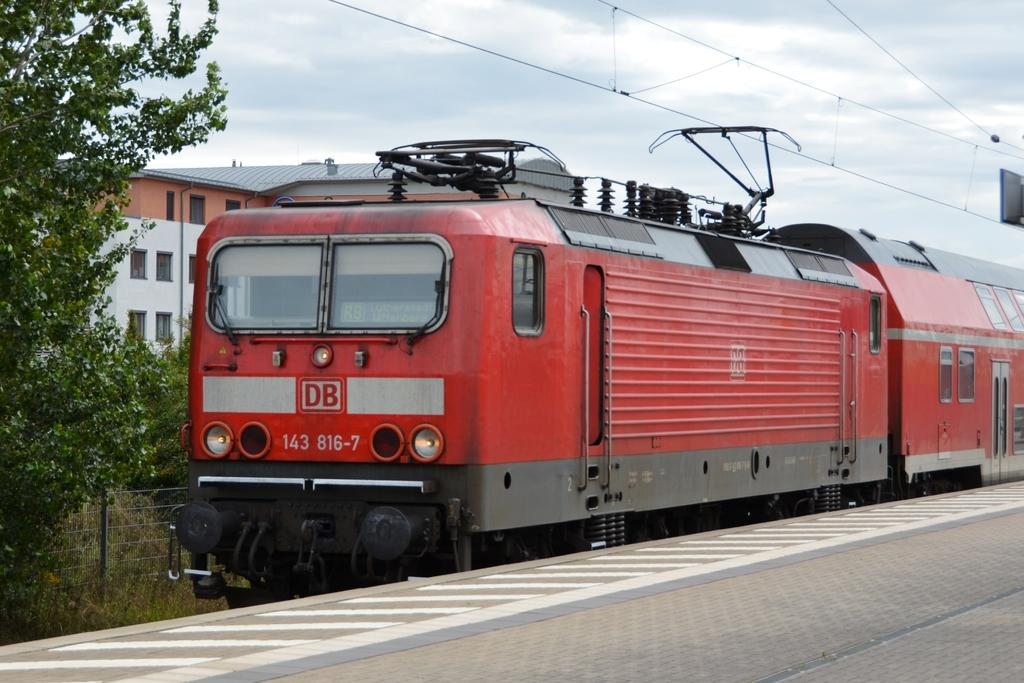<image>
Give a short and clear explanation of the subsequent image. A red train with the letters DB above the numbers 143 816-7, is moving along train tracks. 